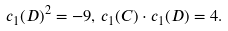<formula> <loc_0><loc_0><loc_500><loc_500>c _ { 1 } ( D ) ^ { 2 } = - 9 , \, c _ { 1 } ( C ) \cdot c _ { 1 } ( D ) = 4 .</formula> 